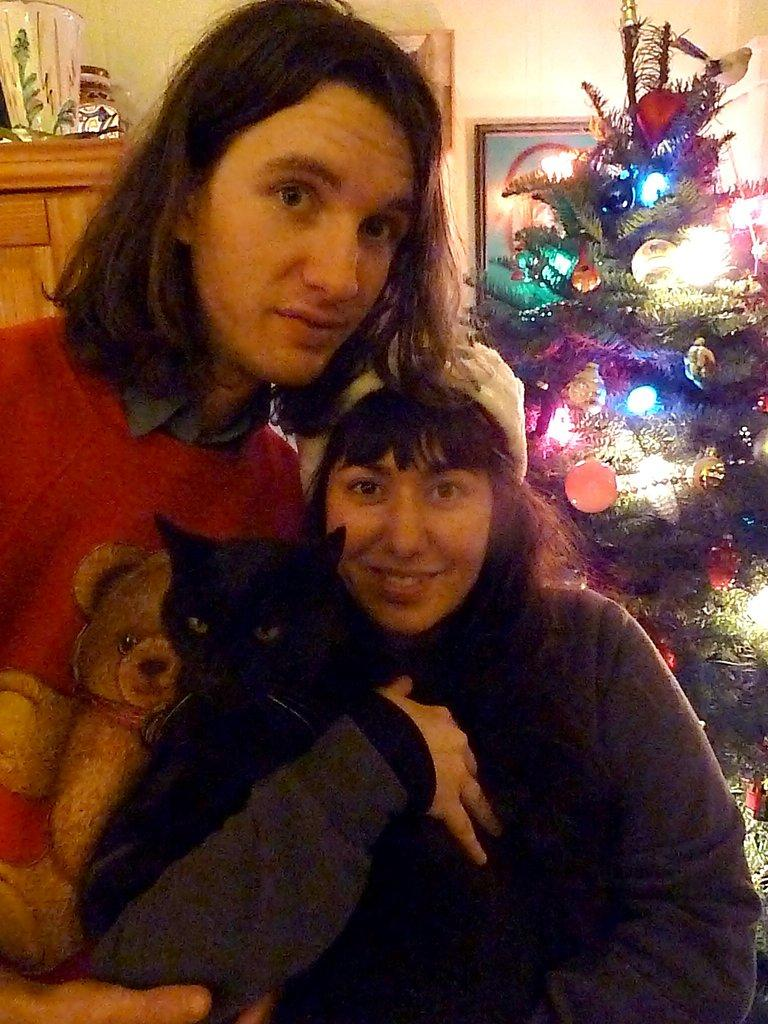How many people are present in the image? There is a man and a woman in the image. What other living creature can be seen in the image? There is a cat in the image. What is visible in the background of the image? There is a Christmas tree, a frame attached to a wall, and a wooden cupboard in the background of the image. What type of reaction does the cat have to the stocking hanging from the fireplace? There is no stocking hanging from a fireplace in the image, and therefore no such reaction can be observed. 